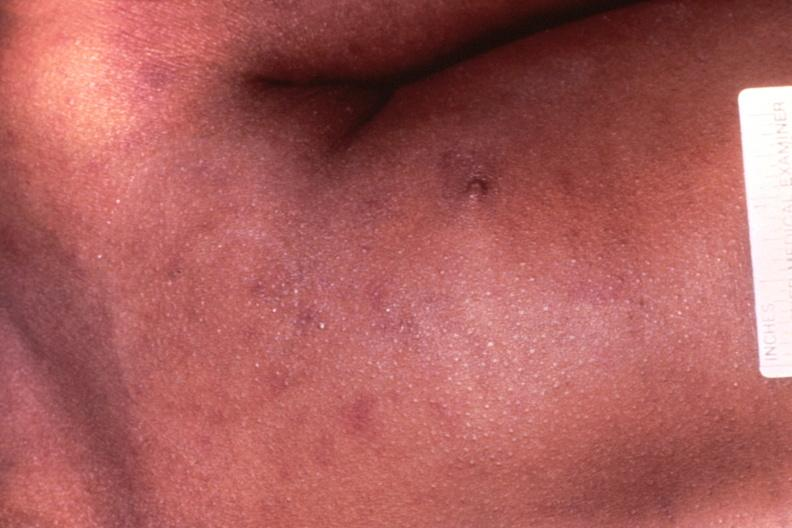does metastatic carcinoma oat cell show meningococcemia, petechia?
Answer the question using a single word or phrase. No 